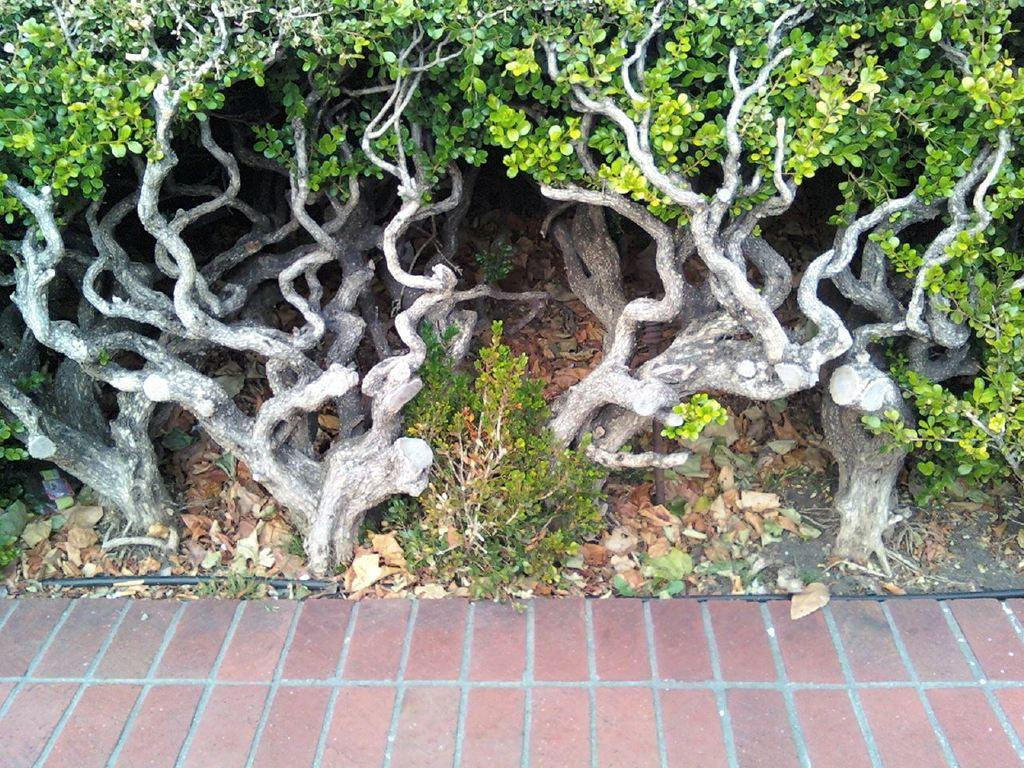What type of surface is in the foreground of the image? There is pavement in the foreground of the image. What can be seen scattered on the pavement? Dry leaves are present in the image. What type of vegetation is visible in the image? Plants are visible in the image. What man-made object is present in the image? A cable is present in the image. What part of a tree can be seen in the image? The roots of a tree are visible in the image. Can you tell me how deep the river is in the image? There is no river present in the image; it features pavement, dry leaves, plants, a cable, and tree roots. What type of credit card is being used in the image? There is no credit card or any financial transaction depicted in the image. 